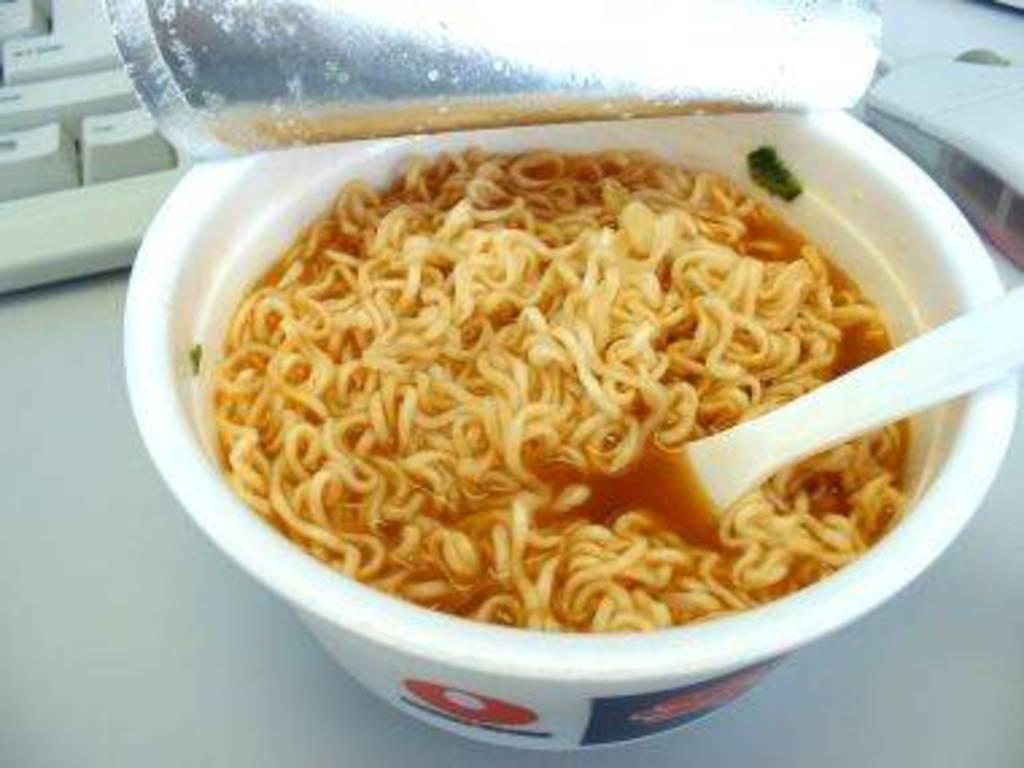In one or two sentences, can you explain what this image depicts? In this image we can see there is a cup of noodles with a spoon and there is a keyboard and mouse on the table. 